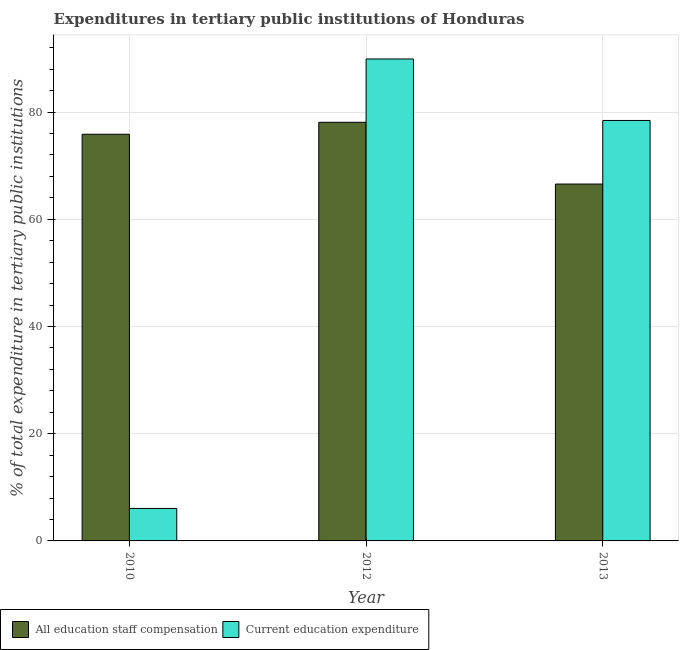How many groups of bars are there?
Your response must be concise. 3. Are the number of bars on each tick of the X-axis equal?
Provide a short and direct response. Yes. In how many cases, is the number of bars for a given year not equal to the number of legend labels?
Provide a succinct answer. 0. What is the expenditure in staff compensation in 2010?
Give a very brief answer. 75.86. Across all years, what is the maximum expenditure in education?
Keep it short and to the point. 89.9. Across all years, what is the minimum expenditure in education?
Keep it short and to the point. 6.06. In which year was the expenditure in staff compensation maximum?
Ensure brevity in your answer.  2012. What is the total expenditure in staff compensation in the graph?
Your answer should be compact. 220.53. What is the difference between the expenditure in staff compensation in 2012 and that in 2013?
Provide a succinct answer. 11.52. What is the difference between the expenditure in education in 2013 and the expenditure in staff compensation in 2012?
Your answer should be very brief. -11.47. What is the average expenditure in education per year?
Keep it short and to the point. 58.13. In the year 2010, what is the difference between the expenditure in education and expenditure in staff compensation?
Your answer should be very brief. 0. In how many years, is the expenditure in staff compensation greater than 72 %?
Provide a succinct answer. 2. What is the ratio of the expenditure in staff compensation in 2010 to that in 2012?
Ensure brevity in your answer.  0.97. Is the expenditure in staff compensation in 2010 less than that in 2012?
Give a very brief answer. Yes. Is the difference between the expenditure in staff compensation in 2010 and 2013 greater than the difference between the expenditure in education in 2010 and 2013?
Your answer should be very brief. No. What is the difference between the highest and the second highest expenditure in education?
Your answer should be compact. 11.47. What is the difference between the highest and the lowest expenditure in education?
Give a very brief answer. 83.85. What does the 2nd bar from the left in 2012 represents?
Give a very brief answer. Current education expenditure. What does the 1st bar from the right in 2013 represents?
Your answer should be very brief. Current education expenditure. Are all the bars in the graph horizontal?
Offer a very short reply. No. How many years are there in the graph?
Give a very brief answer. 3. What is the difference between two consecutive major ticks on the Y-axis?
Offer a very short reply. 20. Are the values on the major ticks of Y-axis written in scientific E-notation?
Provide a succinct answer. No. How many legend labels are there?
Make the answer very short. 2. What is the title of the graph?
Your answer should be very brief. Expenditures in tertiary public institutions of Honduras. Does "Private credit bureau" appear as one of the legend labels in the graph?
Ensure brevity in your answer.  No. What is the label or title of the X-axis?
Provide a short and direct response. Year. What is the label or title of the Y-axis?
Offer a very short reply. % of total expenditure in tertiary public institutions. What is the % of total expenditure in tertiary public institutions in All education staff compensation in 2010?
Ensure brevity in your answer.  75.86. What is the % of total expenditure in tertiary public institutions in Current education expenditure in 2010?
Provide a short and direct response. 6.06. What is the % of total expenditure in tertiary public institutions of All education staff compensation in 2012?
Your response must be concise. 78.09. What is the % of total expenditure in tertiary public institutions of Current education expenditure in 2012?
Keep it short and to the point. 89.9. What is the % of total expenditure in tertiary public institutions of All education staff compensation in 2013?
Give a very brief answer. 66.57. What is the % of total expenditure in tertiary public institutions of Current education expenditure in 2013?
Give a very brief answer. 78.43. Across all years, what is the maximum % of total expenditure in tertiary public institutions in All education staff compensation?
Provide a short and direct response. 78.09. Across all years, what is the maximum % of total expenditure in tertiary public institutions of Current education expenditure?
Make the answer very short. 89.9. Across all years, what is the minimum % of total expenditure in tertiary public institutions of All education staff compensation?
Make the answer very short. 66.57. Across all years, what is the minimum % of total expenditure in tertiary public institutions of Current education expenditure?
Your answer should be very brief. 6.06. What is the total % of total expenditure in tertiary public institutions of All education staff compensation in the graph?
Provide a short and direct response. 220.53. What is the total % of total expenditure in tertiary public institutions of Current education expenditure in the graph?
Provide a short and direct response. 174.39. What is the difference between the % of total expenditure in tertiary public institutions of All education staff compensation in 2010 and that in 2012?
Your response must be concise. -2.23. What is the difference between the % of total expenditure in tertiary public institutions in Current education expenditure in 2010 and that in 2012?
Your answer should be very brief. -83.85. What is the difference between the % of total expenditure in tertiary public institutions in All education staff compensation in 2010 and that in 2013?
Ensure brevity in your answer.  9.29. What is the difference between the % of total expenditure in tertiary public institutions of Current education expenditure in 2010 and that in 2013?
Your answer should be compact. -72.38. What is the difference between the % of total expenditure in tertiary public institutions of All education staff compensation in 2012 and that in 2013?
Make the answer very short. 11.52. What is the difference between the % of total expenditure in tertiary public institutions of Current education expenditure in 2012 and that in 2013?
Ensure brevity in your answer.  11.47. What is the difference between the % of total expenditure in tertiary public institutions of All education staff compensation in 2010 and the % of total expenditure in tertiary public institutions of Current education expenditure in 2012?
Make the answer very short. -14.04. What is the difference between the % of total expenditure in tertiary public institutions of All education staff compensation in 2010 and the % of total expenditure in tertiary public institutions of Current education expenditure in 2013?
Your answer should be very brief. -2.57. What is the difference between the % of total expenditure in tertiary public institutions of All education staff compensation in 2012 and the % of total expenditure in tertiary public institutions of Current education expenditure in 2013?
Provide a succinct answer. -0.34. What is the average % of total expenditure in tertiary public institutions in All education staff compensation per year?
Your response must be concise. 73.51. What is the average % of total expenditure in tertiary public institutions of Current education expenditure per year?
Provide a succinct answer. 58.13. In the year 2010, what is the difference between the % of total expenditure in tertiary public institutions in All education staff compensation and % of total expenditure in tertiary public institutions in Current education expenditure?
Ensure brevity in your answer.  69.81. In the year 2012, what is the difference between the % of total expenditure in tertiary public institutions in All education staff compensation and % of total expenditure in tertiary public institutions in Current education expenditure?
Ensure brevity in your answer.  -11.81. In the year 2013, what is the difference between the % of total expenditure in tertiary public institutions of All education staff compensation and % of total expenditure in tertiary public institutions of Current education expenditure?
Provide a short and direct response. -11.86. What is the ratio of the % of total expenditure in tertiary public institutions in All education staff compensation in 2010 to that in 2012?
Keep it short and to the point. 0.97. What is the ratio of the % of total expenditure in tertiary public institutions in Current education expenditure in 2010 to that in 2012?
Ensure brevity in your answer.  0.07. What is the ratio of the % of total expenditure in tertiary public institutions in All education staff compensation in 2010 to that in 2013?
Your answer should be compact. 1.14. What is the ratio of the % of total expenditure in tertiary public institutions in Current education expenditure in 2010 to that in 2013?
Your answer should be compact. 0.08. What is the ratio of the % of total expenditure in tertiary public institutions in All education staff compensation in 2012 to that in 2013?
Give a very brief answer. 1.17. What is the ratio of the % of total expenditure in tertiary public institutions of Current education expenditure in 2012 to that in 2013?
Give a very brief answer. 1.15. What is the difference between the highest and the second highest % of total expenditure in tertiary public institutions of All education staff compensation?
Give a very brief answer. 2.23. What is the difference between the highest and the second highest % of total expenditure in tertiary public institutions in Current education expenditure?
Ensure brevity in your answer.  11.47. What is the difference between the highest and the lowest % of total expenditure in tertiary public institutions of All education staff compensation?
Provide a succinct answer. 11.52. What is the difference between the highest and the lowest % of total expenditure in tertiary public institutions in Current education expenditure?
Your response must be concise. 83.85. 